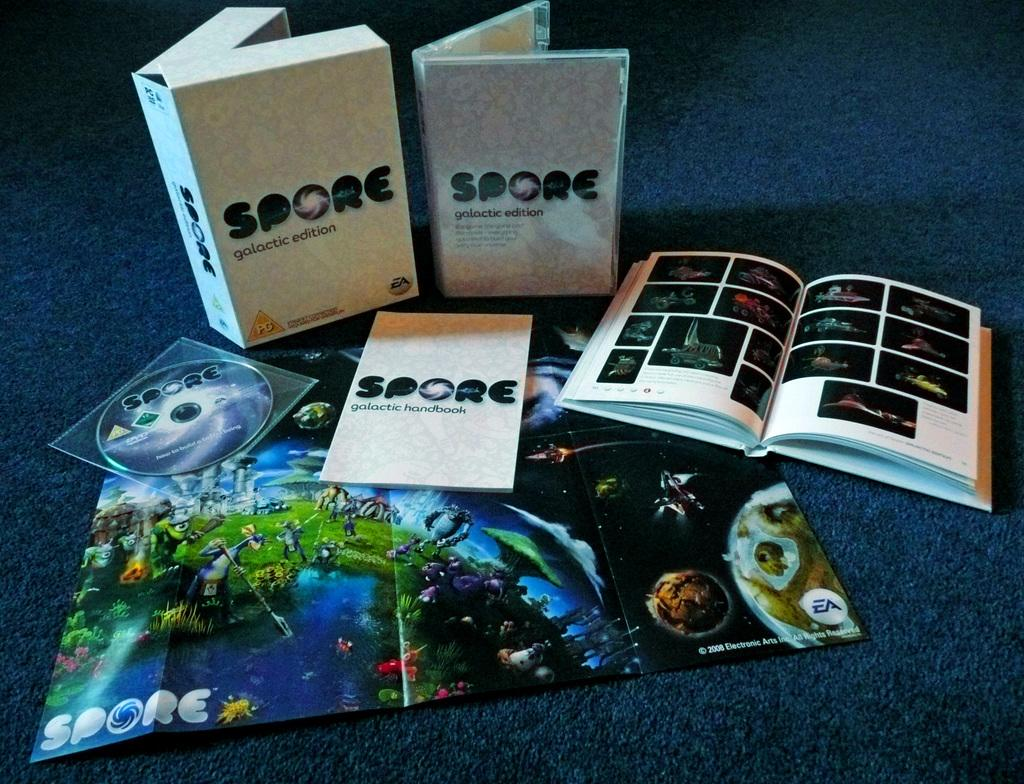<image>
Describe the image concisely. An educational program called SPORE with multiple parts. 